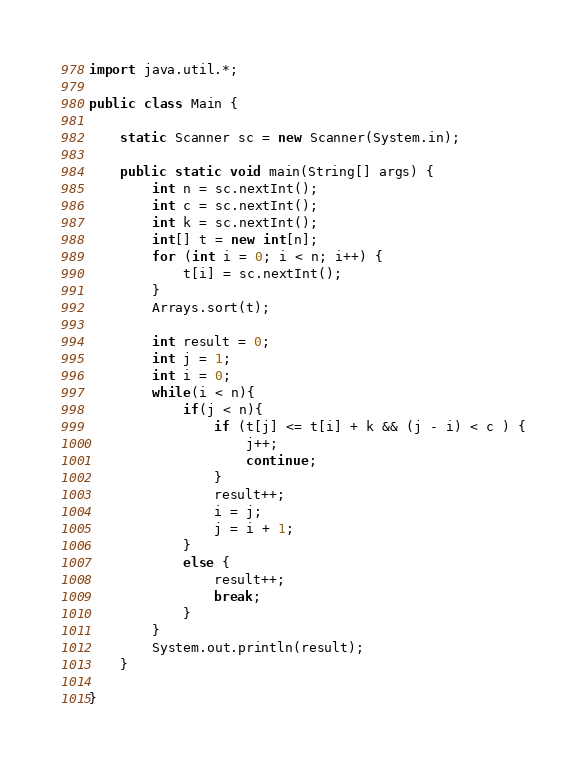<code> <loc_0><loc_0><loc_500><loc_500><_Java_>import java.util.*;

public class Main {
	
	static Scanner sc = new Scanner(System.in);
	
	public static void main(String[] args) {
		int n = sc.nextInt();
		int c = sc.nextInt();
		int k = sc.nextInt();
		int[] t = new int[n];
		for (int i = 0; i < n; i++) {
			t[i] = sc.nextInt();
		}
		Arrays.sort(t);
		
		int result = 0;
		int j = 1;
		int i = 0;
		while(i < n){
			if(j < n){
				if (t[j] <= t[i] + k && (j - i) < c ) {
					j++;
					continue;
				}
				result++;
				i = j;
				j = i + 1;
			}
			else {
				result++;
				break;
			}
		}
		System.out.println(result);
	}

}
</code> 